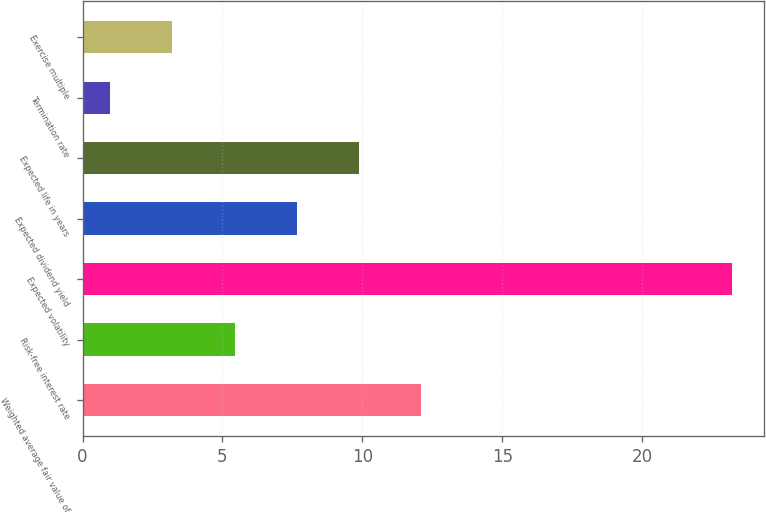<chart> <loc_0><loc_0><loc_500><loc_500><bar_chart><fcel>Weighted average fair value of<fcel>Risk-free interest rate<fcel>Expected volatility<fcel>Expected dividend yield<fcel>Expected life in years<fcel>Termination rate<fcel>Exercise multiple<nl><fcel>12.09<fcel>5.43<fcel>23.2<fcel>7.65<fcel>9.87<fcel>0.99<fcel>3.21<nl></chart> 